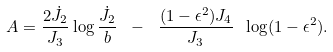<formula> <loc_0><loc_0><loc_500><loc_500>A = { \frac { 2 \dot { J } _ { 2 } } { J _ { 3 } } } \log { \frac { \dot { J } _ { 2 } } { b } } \ - \ { \frac { ( 1 - \epsilon ^ { 2 } ) J _ { 4 } } { J _ { 3 } } } \ \log ( 1 - \epsilon ^ { 2 } ) .</formula> 